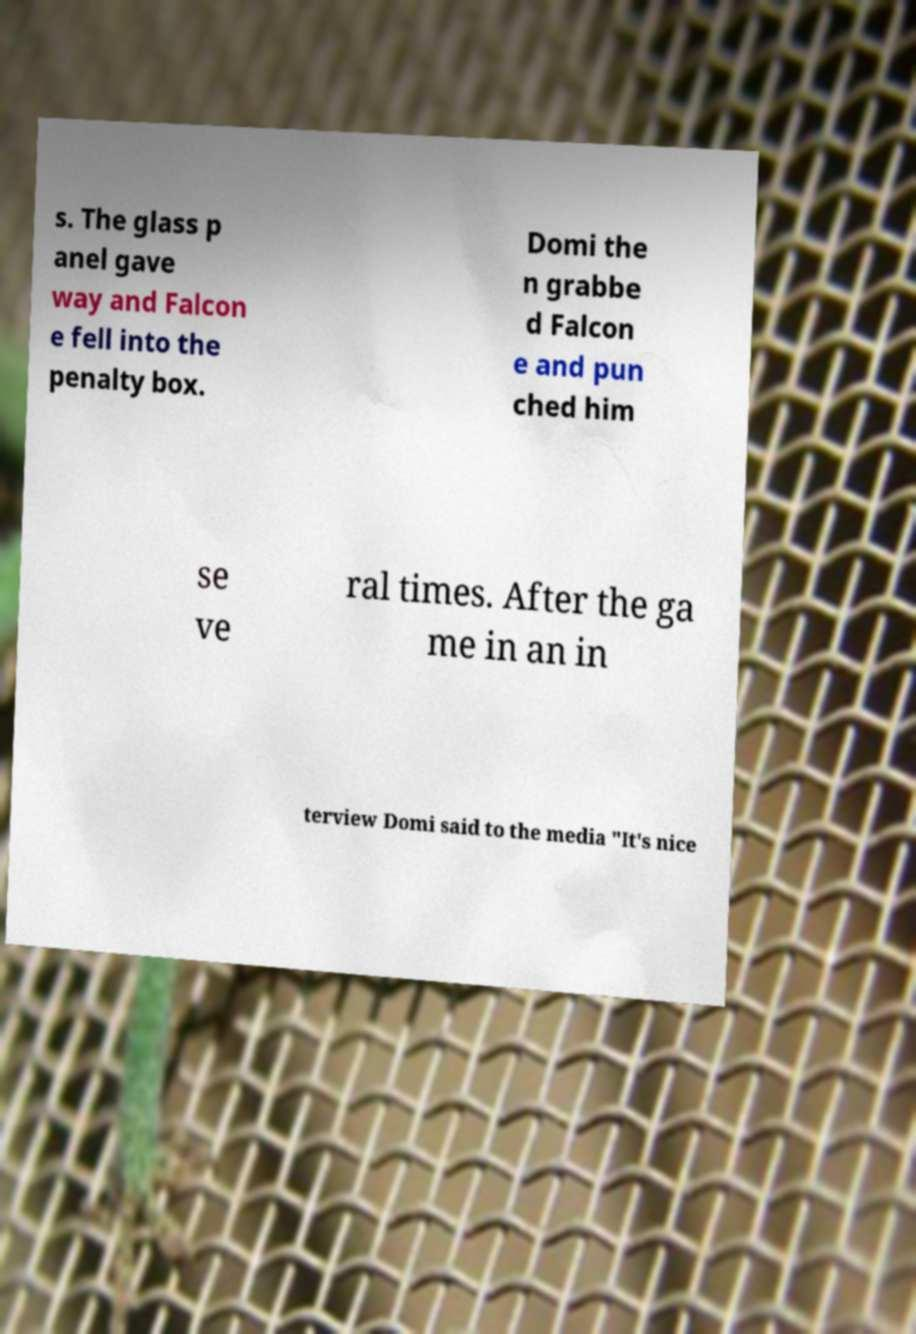Could you extract and type out the text from this image? s. The glass p anel gave way and Falcon e fell into the penalty box. Domi the n grabbe d Falcon e and pun ched him se ve ral times. After the ga me in an in terview Domi said to the media "It's nice 